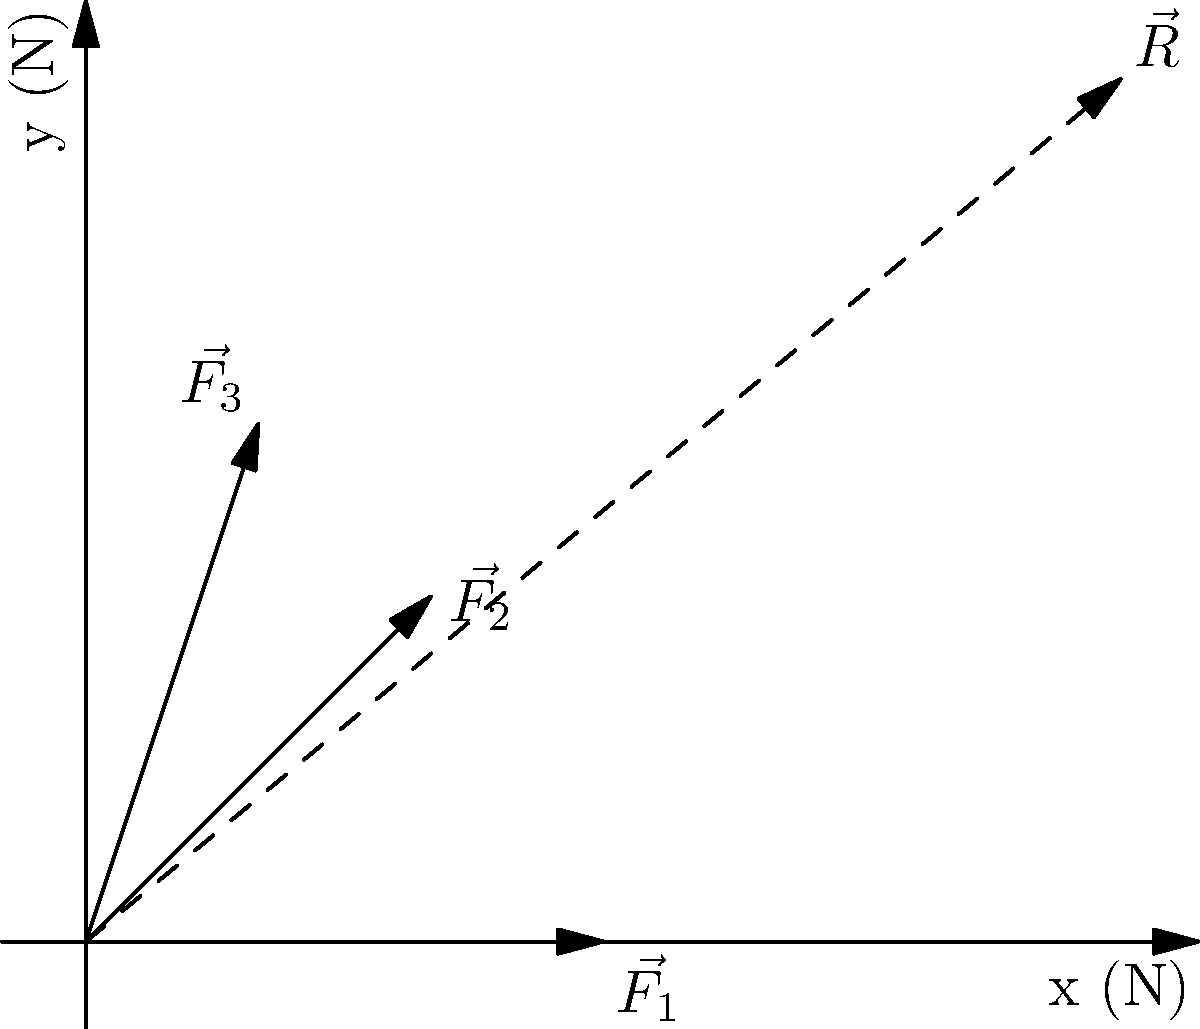At a Tokio Hotel concert, three enthusiastic fans are pushing towards the stage. Their forces are represented by vectors $\vec{F_1} = 3\hat{i}$, $\vec{F_2} = 2\hat{i} + 2\hat{j}$, and $\vec{F_3} = \hat{i} + 3\hat{j}$, where $\hat{i}$ and $\hat{j}$ are unit vectors in the x and y directions respectively, and forces are measured in Newtons. Calculate the magnitude of the resultant force $\vec{R}$ acting on the stage barrier. To find the magnitude of the resultant force, we need to follow these steps:

1) First, we add all the force vectors:
   $\vec{R} = \vec{F_1} + \vec{F_2} + \vec{F_3}$

2) Let's add the x-components:
   $R_x = 3 + 2 + 1 = 6$ N

3) Now, let's add the y-components:
   $R_y = 0 + 2 + 3 = 5$ N

4) So, the resultant vector is:
   $\vec{R} = 6\hat{i} + 5\hat{j}$

5) To find the magnitude of this vector, we use the Pythagorean theorem:
   $|\vec{R}| = \sqrt{R_x^2 + R_y^2} = \sqrt{6^2 + 5^2} = \sqrt{36 + 25} = \sqrt{61}$

6) Simplifying:
   $|\vec{R}| = \sqrt{61}$ N ≈ 7.81 N

Therefore, the magnitude of the resultant force acting on the stage barrier is $\sqrt{61}$ N or approximately 7.81 N.
Answer: $\sqrt{61}$ N 